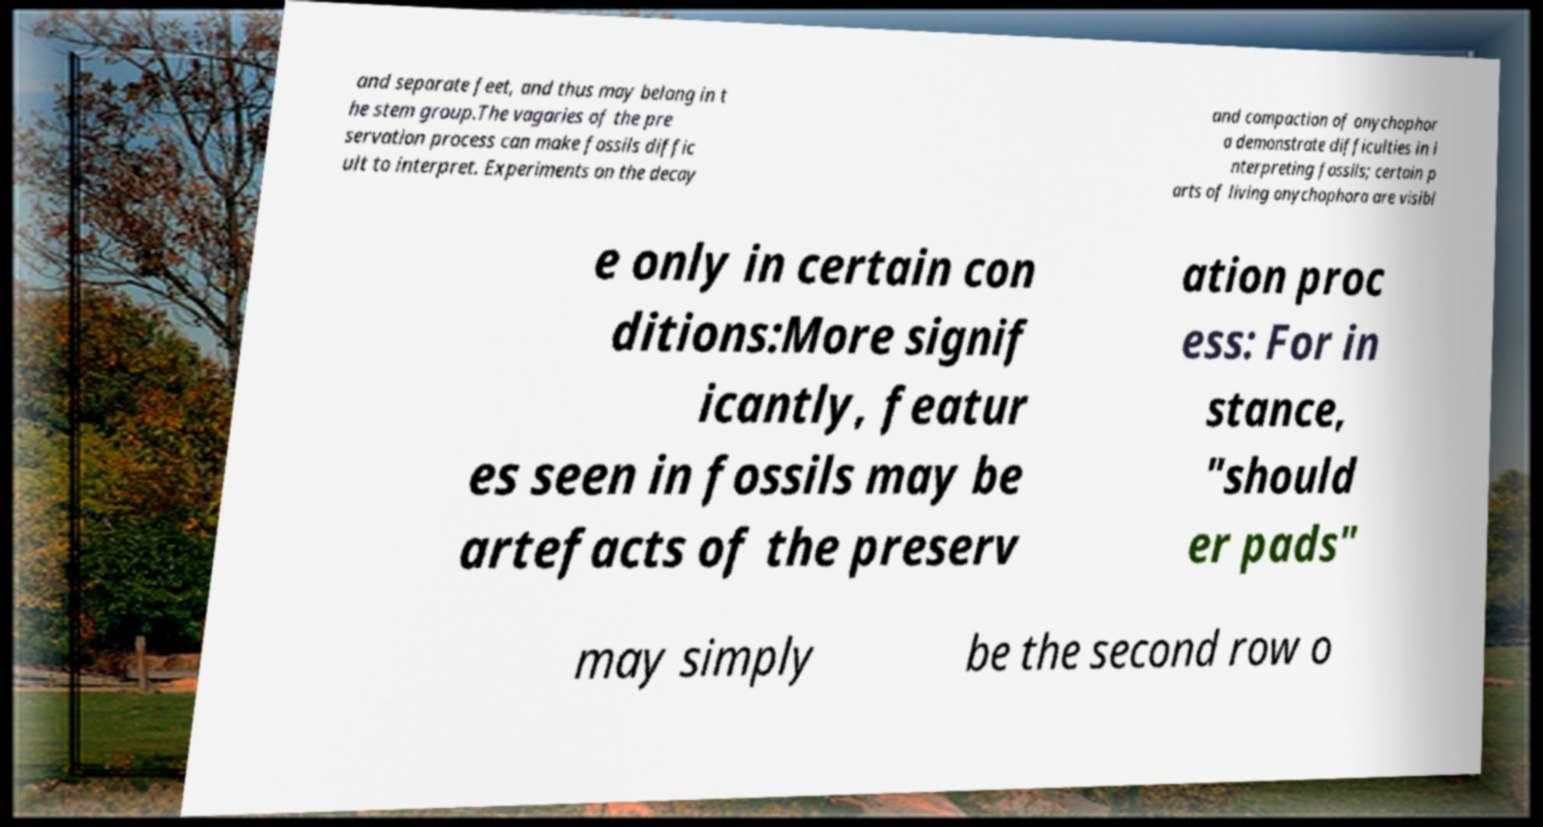I need the written content from this picture converted into text. Can you do that? and separate feet, and thus may belong in t he stem group.The vagaries of the pre servation process can make fossils diffic ult to interpret. Experiments on the decay and compaction of onychophor a demonstrate difficulties in i nterpreting fossils; certain p arts of living onychophora are visibl e only in certain con ditions:More signif icantly, featur es seen in fossils may be artefacts of the preserv ation proc ess: For in stance, "should er pads" may simply be the second row o 